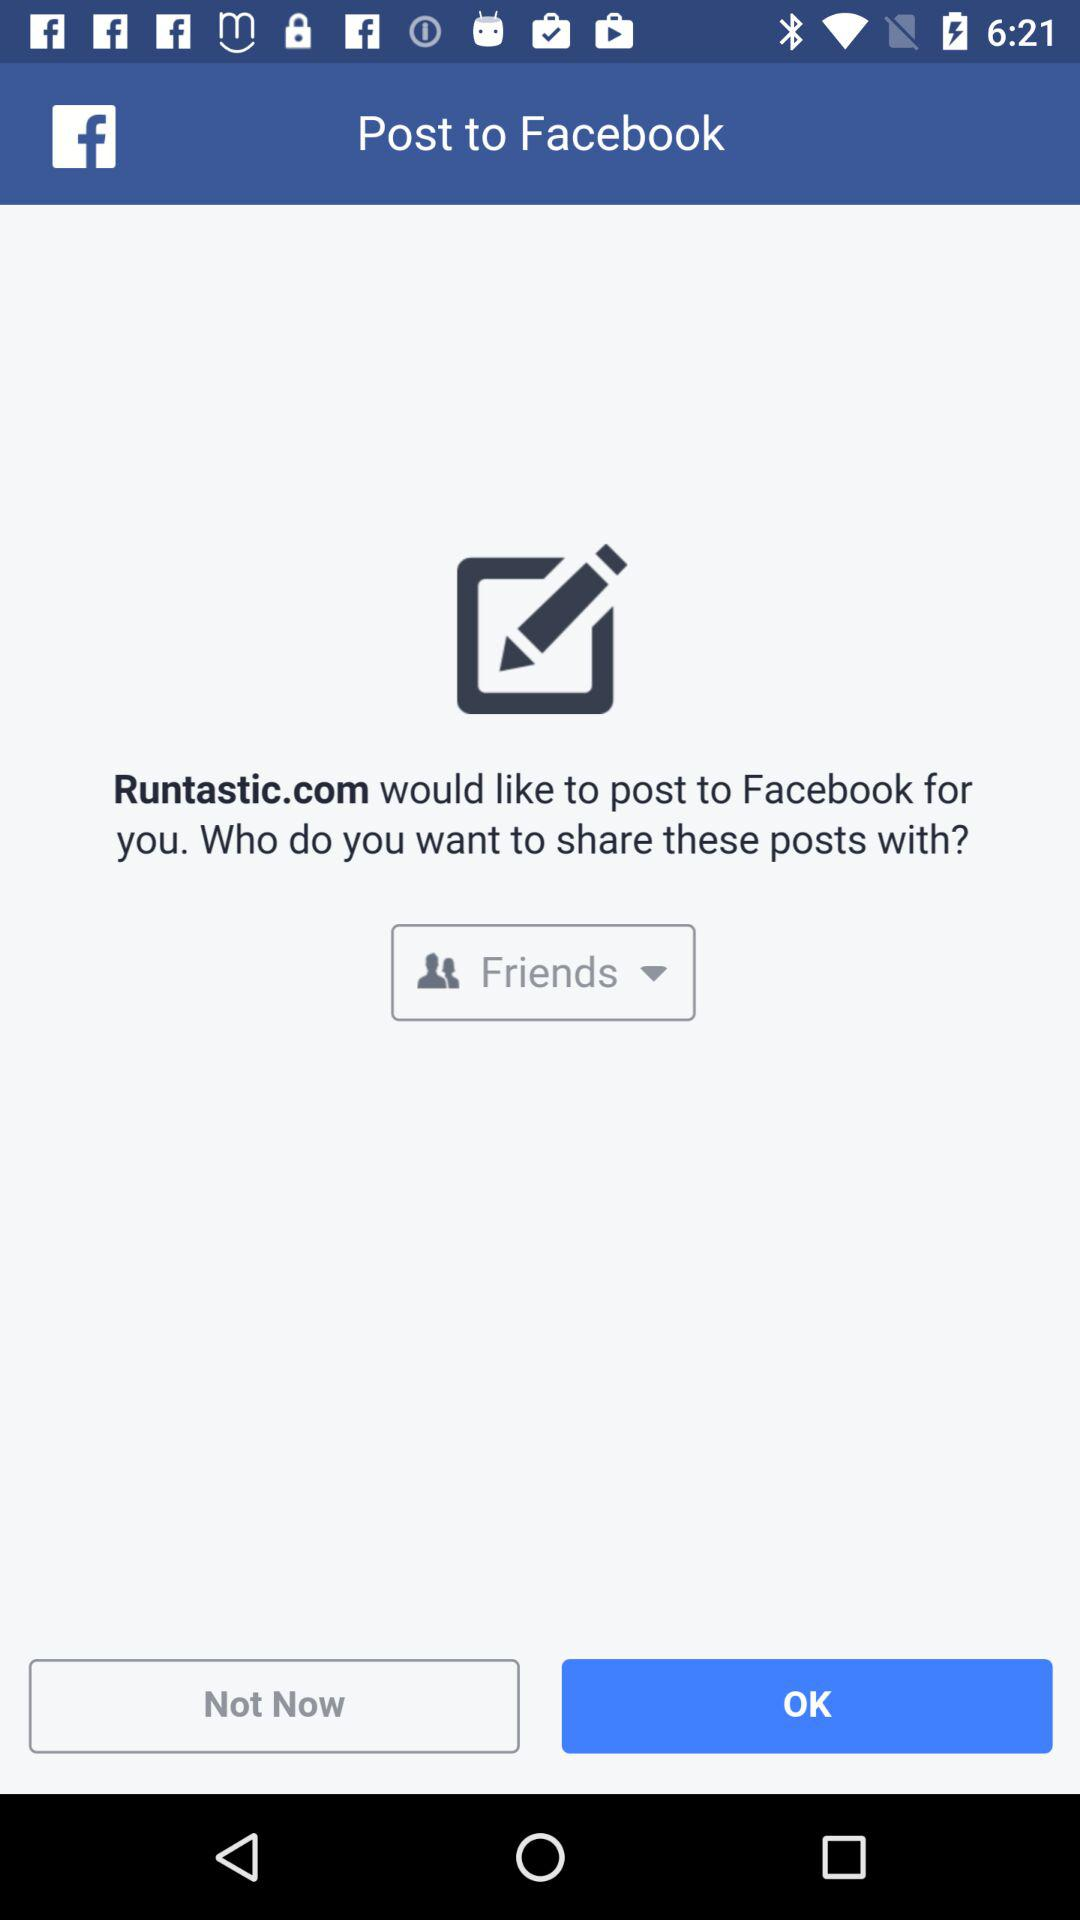What is the application name? The application names are "Runtastic.com" and "Facebook". 